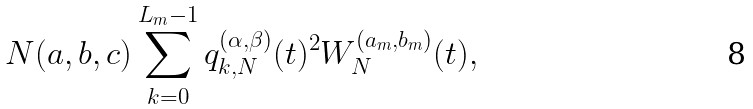<formula> <loc_0><loc_0><loc_500><loc_500>N ( a , b , c ) \sum _ { k = 0 } ^ { L _ { m } - 1 } q _ { k , N } ^ { ( \alpha , \beta ) } ( t ) ^ { 2 } W _ { N } ^ { ( a _ { m } , b _ { m } ) } ( t ) ,</formula> 